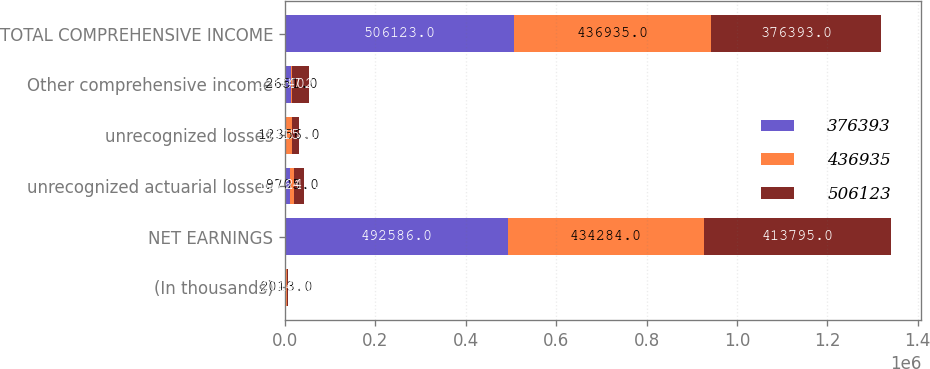Convert chart. <chart><loc_0><loc_0><loc_500><loc_500><stacked_bar_chart><ecel><fcel>(In thousands)<fcel>NET EARNINGS<fcel>unrecognized actuarial losses<fcel>unrecognized losses<fcel>Other comprehensive income<fcel>TOTAL COMPREHENSIVE INCOME<nl><fcel>376393<fcel>2014<fcel>492586<fcel>10764<fcel>2773<fcel>13537<fcel>506123<nl><fcel>436935<fcel>2013<fcel>434284<fcel>9705<fcel>12356<fcel>2651<fcel>436935<nl><fcel>506123<fcel>2012<fcel>413795<fcel>22246<fcel>15156<fcel>37402<fcel>376393<nl></chart> 